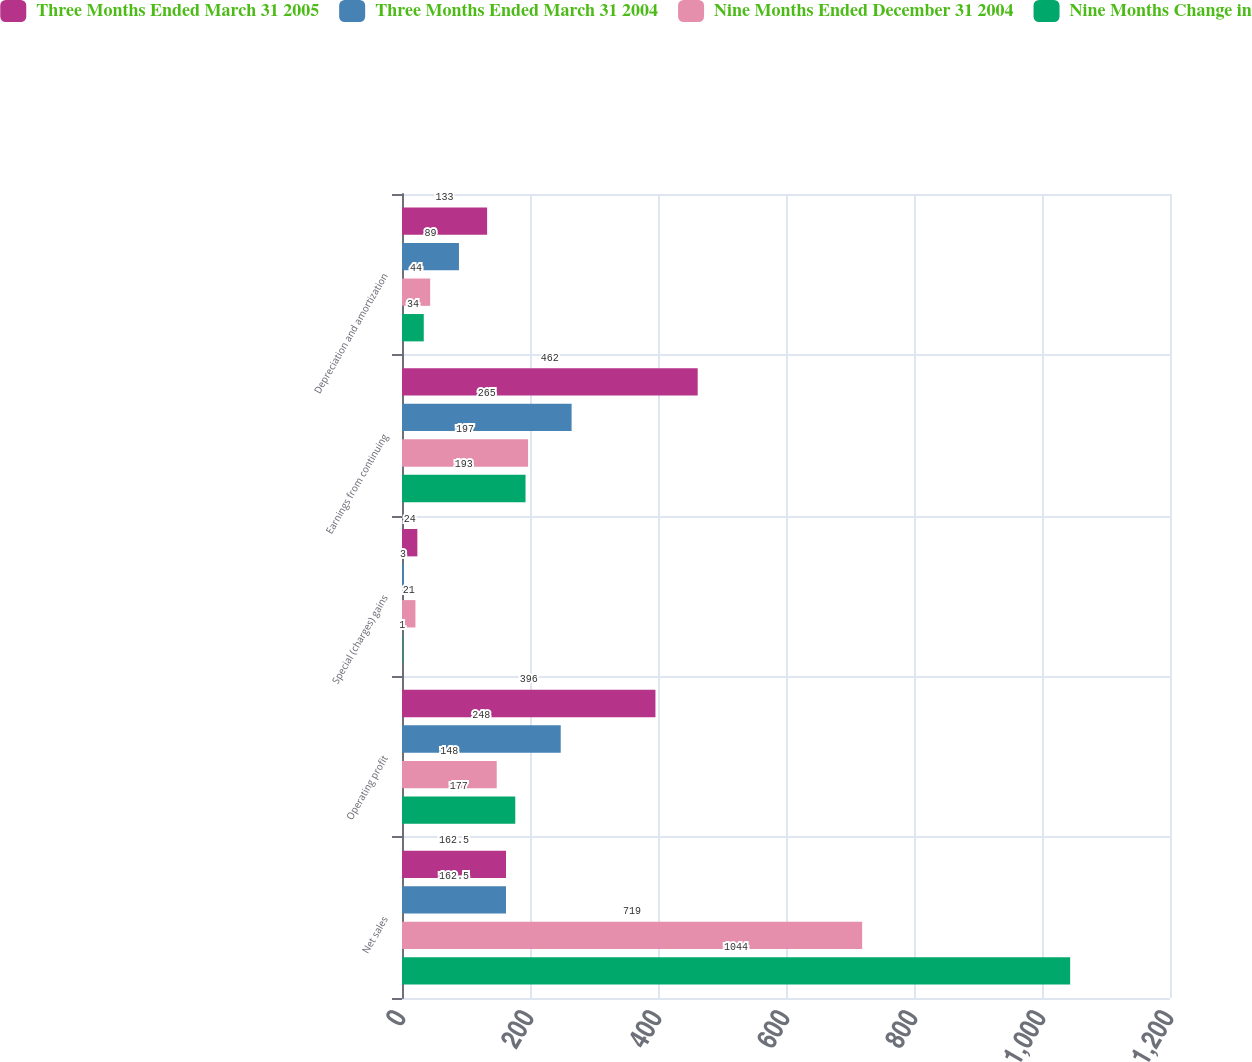Convert chart to OTSL. <chart><loc_0><loc_0><loc_500><loc_500><stacked_bar_chart><ecel><fcel>Net sales<fcel>Operating profit<fcel>Special (charges) gains<fcel>Earnings from continuing<fcel>Depreciation and amortization<nl><fcel>Three Months Ended March 31 2005<fcel>162.5<fcel>396<fcel>24<fcel>462<fcel>133<nl><fcel>Three Months Ended March 31 2004<fcel>162.5<fcel>248<fcel>3<fcel>265<fcel>89<nl><fcel>Nine Months Ended December 31 2004<fcel>719<fcel>148<fcel>21<fcel>197<fcel>44<nl><fcel>Nine Months Change in<fcel>1044<fcel>177<fcel>1<fcel>193<fcel>34<nl></chart> 